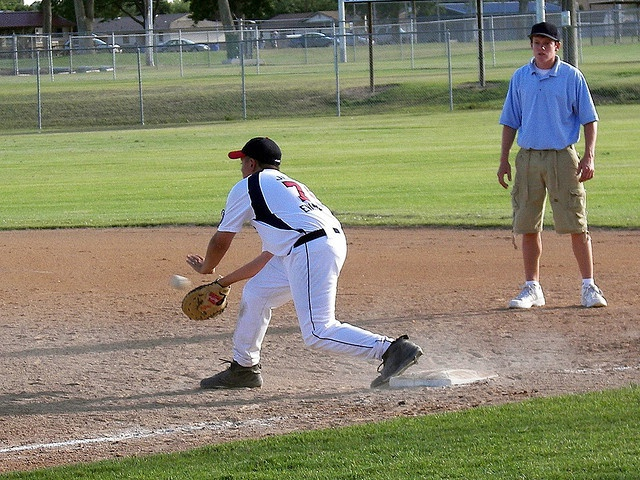Describe the objects in this image and their specific colors. I can see people in darkgreen, darkgray, black, and white tones, people in darkgreen, gray, blue, and maroon tones, baseball glove in darkgreen, maroon, black, and gray tones, car in darkgreen, gray, purple, and black tones, and car in darkgreen, gray, and purple tones in this image. 